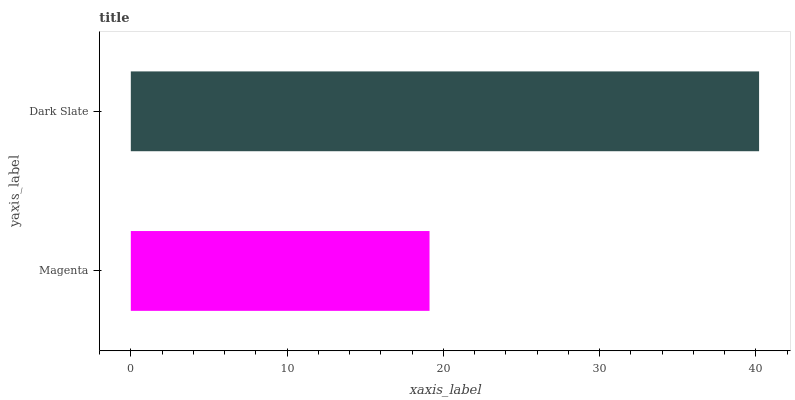Is Magenta the minimum?
Answer yes or no. Yes. Is Dark Slate the maximum?
Answer yes or no. Yes. Is Dark Slate the minimum?
Answer yes or no. No. Is Dark Slate greater than Magenta?
Answer yes or no. Yes. Is Magenta less than Dark Slate?
Answer yes or no. Yes. Is Magenta greater than Dark Slate?
Answer yes or no. No. Is Dark Slate less than Magenta?
Answer yes or no. No. Is Dark Slate the high median?
Answer yes or no. Yes. Is Magenta the low median?
Answer yes or no. Yes. Is Magenta the high median?
Answer yes or no. No. Is Dark Slate the low median?
Answer yes or no. No. 